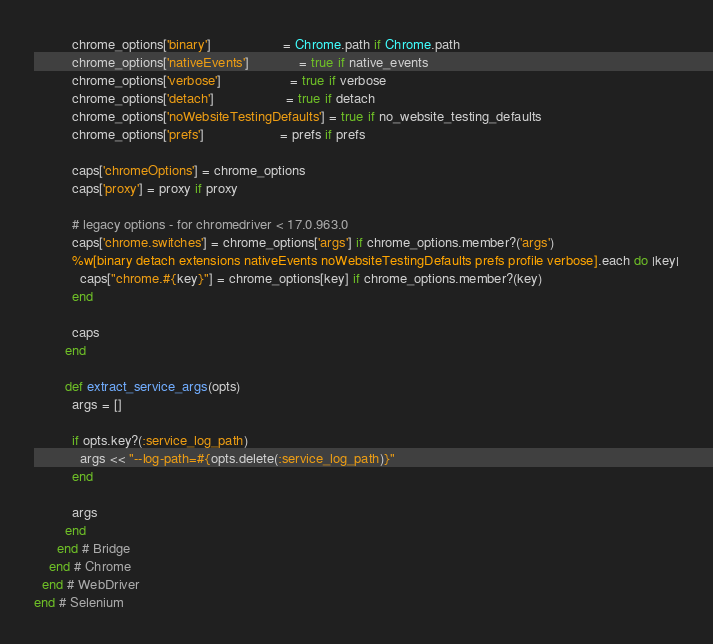<code> <loc_0><loc_0><loc_500><loc_500><_Ruby_>          chrome_options['binary']                   = Chrome.path if Chrome.path
          chrome_options['nativeEvents']             = true if native_events
          chrome_options['verbose']                  = true if verbose
          chrome_options['detach']                   = true if detach
          chrome_options['noWebsiteTestingDefaults'] = true if no_website_testing_defaults
          chrome_options['prefs']                    = prefs if prefs

          caps['chromeOptions'] = chrome_options
          caps['proxy'] = proxy if proxy

          # legacy options - for chromedriver < 17.0.963.0
          caps['chrome.switches'] = chrome_options['args'] if chrome_options.member?('args')
          %w[binary detach extensions nativeEvents noWebsiteTestingDefaults prefs profile verbose].each do |key|
            caps["chrome.#{key}"] = chrome_options[key] if chrome_options.member?(key)
          end

          caps
        end

        def extract_service_args(opts)
          args = []

          if opts.key?(:service_log_path)
            args << "--log-path=#{opts.delete(:service_log_path)}"
          end

          args
        end
      end # Bridge
    end # Chrome
  end # WebDriver
end # Selenium
</code> 